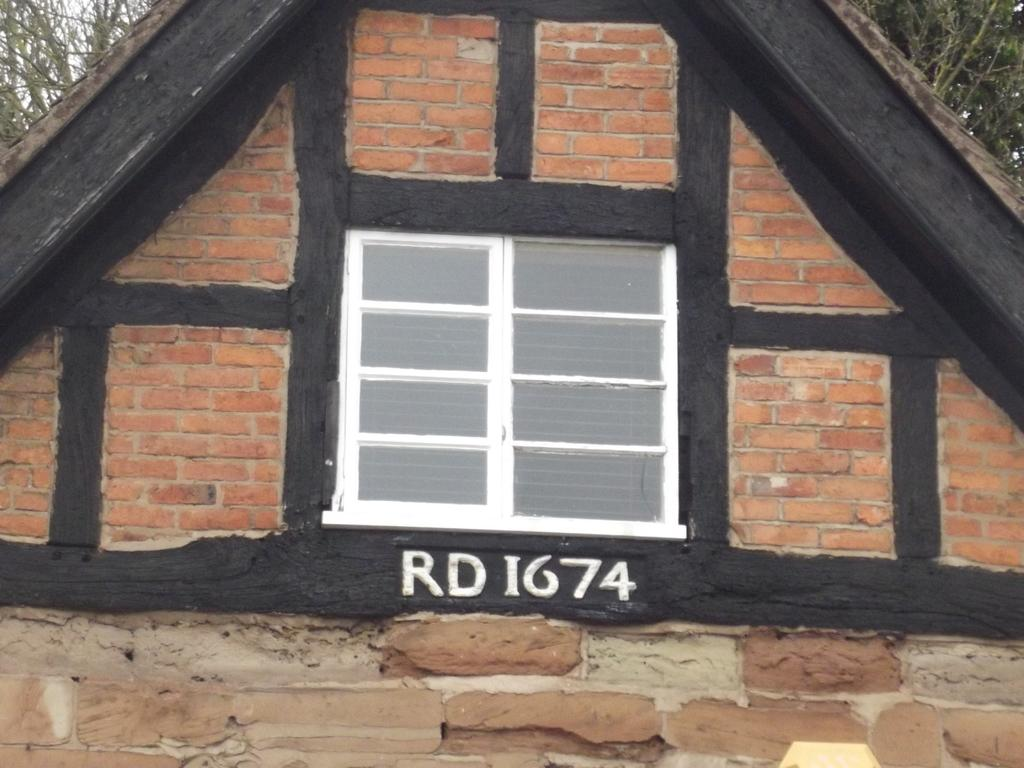What part of a house is shown in the image? The image shows the roof of a house. What features can be seen on the roof? There are windows and text visible on the roof. What can be seen in the background of the image? There are trees in the image. How many stones are visible on the roof in the image? There are no stones visible on the roof in the image. What type of number is written on the roof in the image? There is no number visible on the roof in the image. 